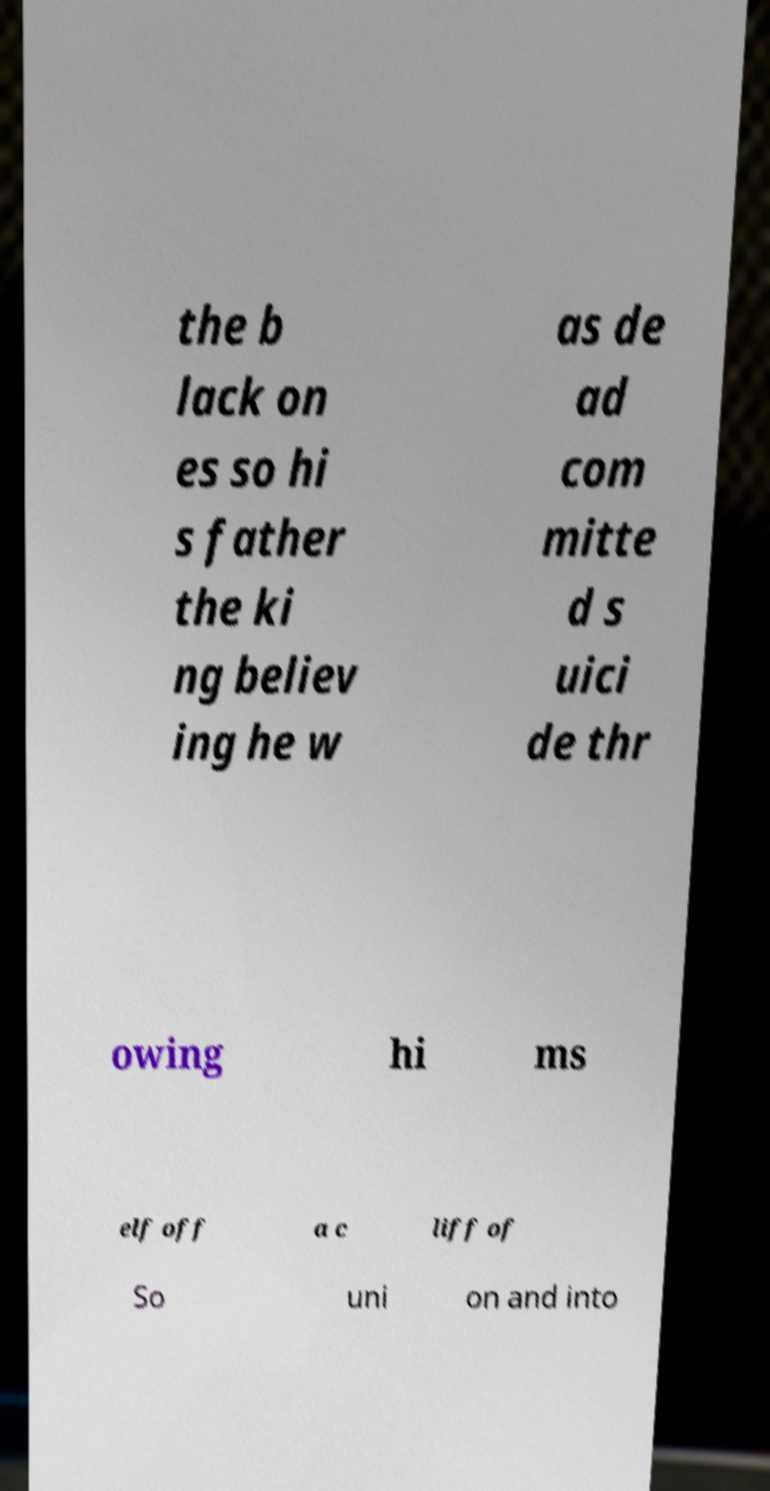Can you read and provide the text displayed in the image?This photo seems to have some interesting text. Can you extract and type it out for me? the b lack on es so hi s father the ki ng believ ing he w as de ad com mitte d s uici de thr owing hi ms elf off a c liff of So uni on and into 